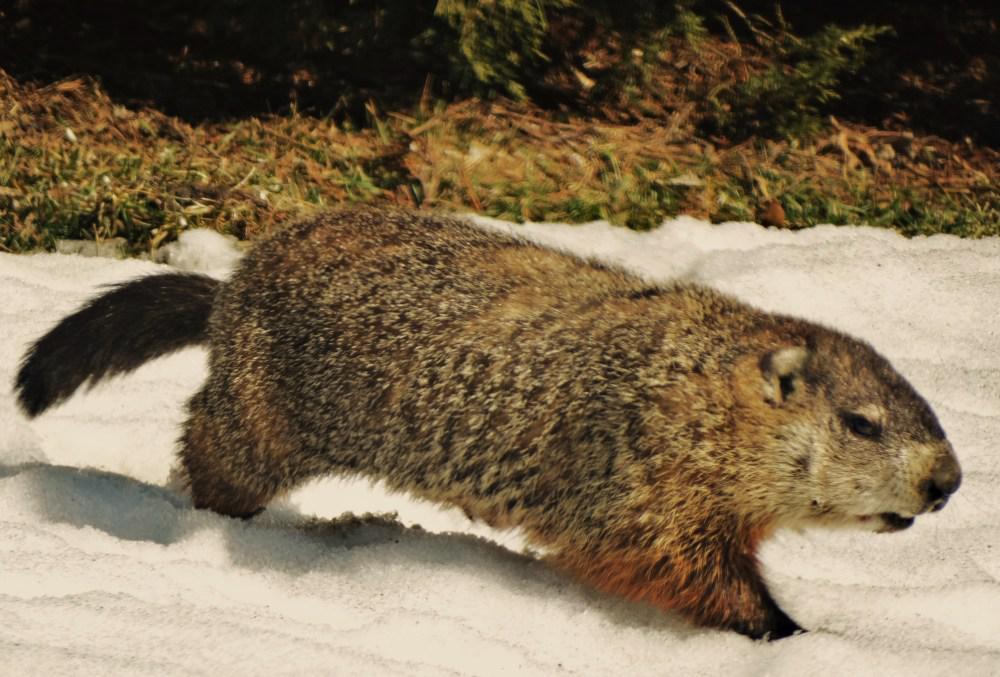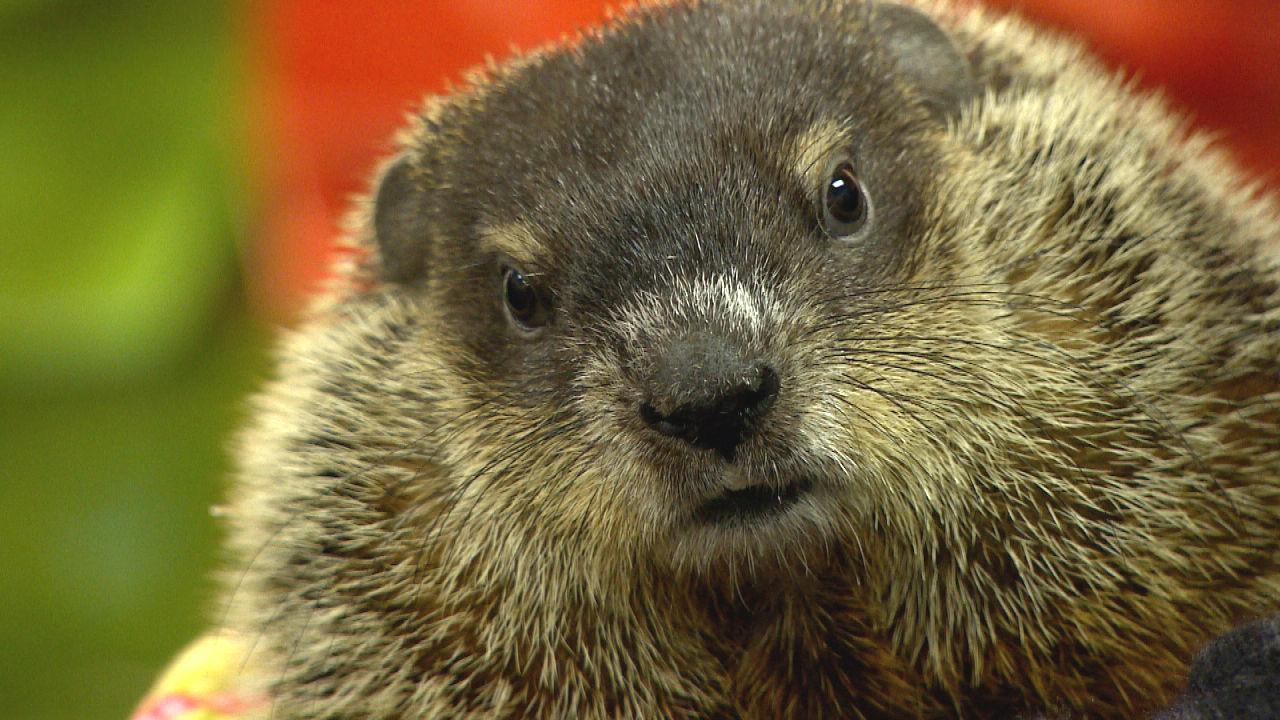The first image is the image on the left, the second image is the image on the right. Assess this claim about the two images: "the creature in the left image has its mouth wide open". Correct or not? Answer yes or no. No. The first image is the image on the left, the second image is the image on the right. For the images displayed, is the sentence "There are green fields in both of them." factually correct? Answer yes or no. No. 